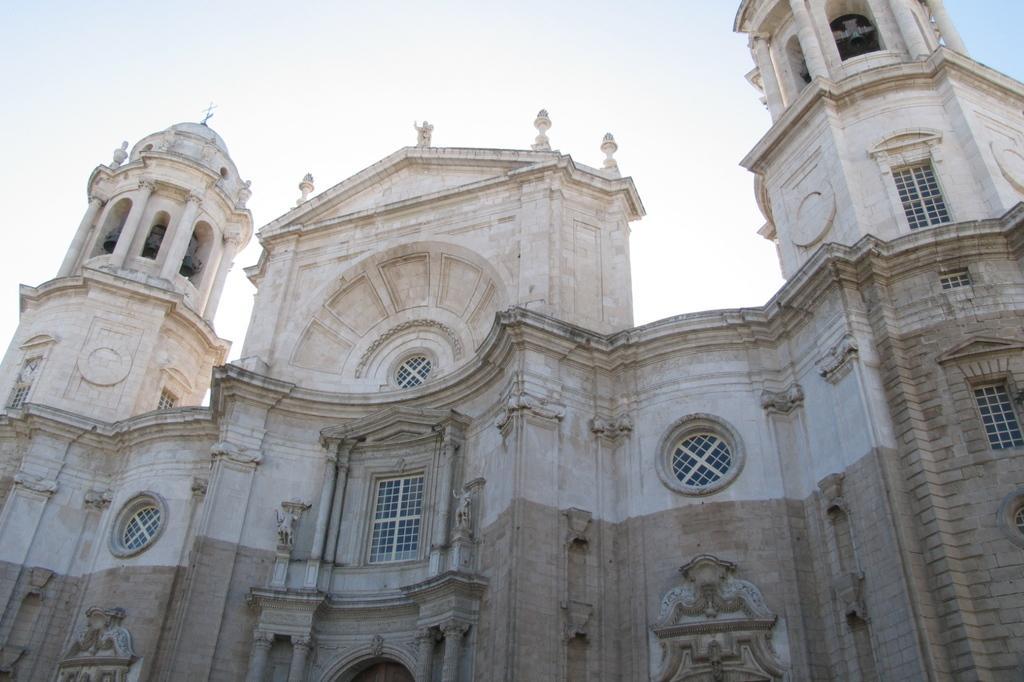How would you summarize this image in a sentence or two? In this image I can see a building which is brown and cream in color, few windows of the building and few beers in the top of the building. In the background I can see the sky. 